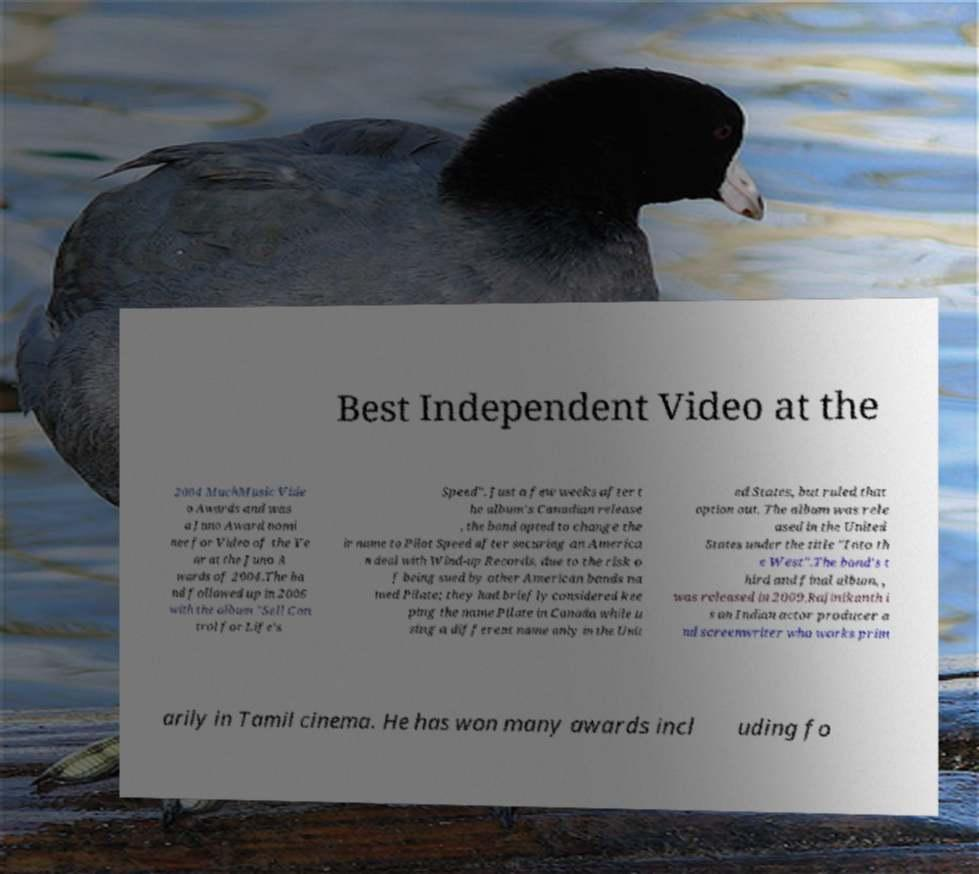For documentation purposes, I need the text within this image transcribed. Could you provide that? Best Independent Video at the 2004 MuchMusic Vide o Awards and was a Juno Award nomi nee for Video of the Ye ar at the Juno A wards of 2004.The ba nd followed up in 2006 with the album "Sell Con trol for Life's Speed". Just a few weeks after t he album's Canadian release , the band opted to change the ir name to Pilot Speed after securing an America n deal with Wind-up Records, due to the risk o f being sued by other American bands na med Pilate; they had briefly considered kee ping the name Pilate in Canada while u sing a different name only in the Unit ed States, but ruled that option out. The album was rele ased in the United States under the title "Into th e West".The band's t hird and final album, , was released in 2009.Rajinikanth i s an Indian actor producer a nd screenwriter who works prim arily in Tamil cinema. He has won many awards incl uding fo 